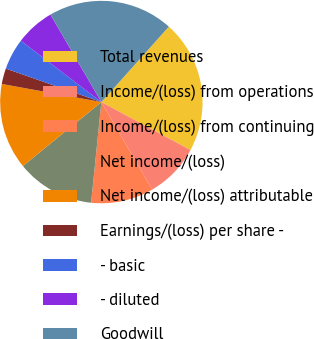<chart> <loc_0><loc_0><loc_500><loc_500><pie_chart><fcel>Total revenues<fcel>Income/(loss) from operations<fcel>Income/(loss) from continuing<fcel>Net income/(loss)<fcel>Net income/(loss) attributable<fcel>Earnings/(loss) per share -<fcel>- basic<fcel>- diluted<fcel>Goodwill<nl><fcel>21.25%<fcel>8.75%<fcel>10.0%<fcel>12.5%<fcel>13.75%<fcel>2.5%<fcel>5.0%<fcel>6.25%<fcel>20.0%<nl></chart> 